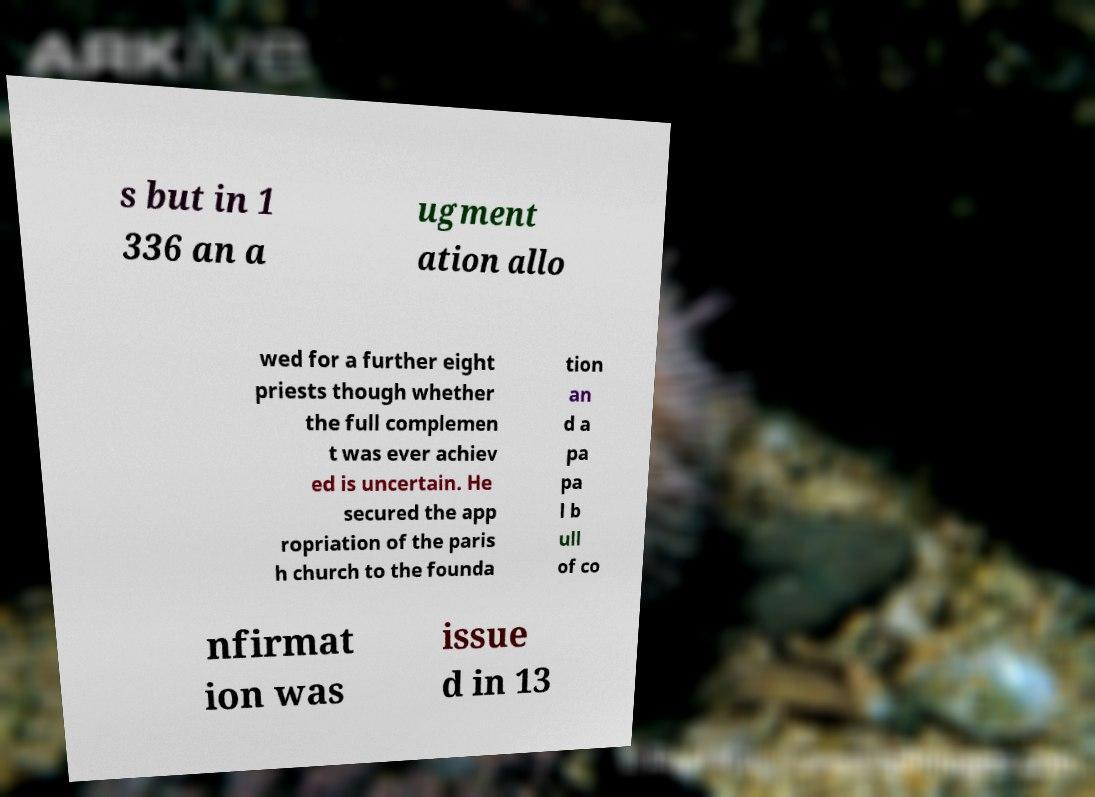Please read and relay the text visible in this image. What does it say? s but in 1 336 an a ugment ation allo wed for a further eight priests though whether the full complemen t was ever achiev ed is uncertain. He secured the app ropriation of the paris h church to the founda tion an d a pa pa l b ull of co nfirmat ion was issue d in 13 